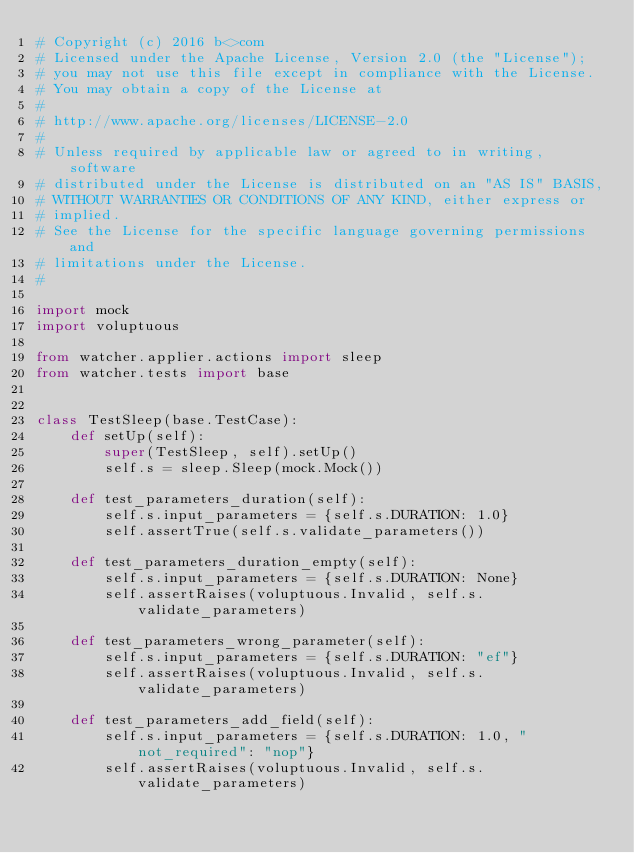Convert code to text. <code><loc_0><loc_0><loc_500><loc_500><_Python_># Copyright (c) 2016 b<>com
# Licensed under the Apache License, Version 2.0 (the "License");
# you may not use this file except in compliance with the License.
# You may obtain a copy of the License at
#
# http://www.apache.org/licenses/LICENSE-2.0
#
# Unless required by applicable law or agreed to in writing, software
# distributed under the License is distributed on an "AS IS" BASIS,
# WITHOUT WARRANTIES OR CONDITIONS OF ANY KIND, either express or
# implied.
# See the License for the specific language governing permissions and
# limitations under the License.
#

import mock
import voluptuous

from watcher.applier.actions import sleep
from watcher.tests import base


class TestSleep(base.TestCase):
    def setUp(self):
        super(TestSleep, self).setUp()
        self.s = sleep.Sleep(mock.Mock())

    def test_parameters_duration(self):
        self.s.input_parameters = {self.s.DURATION: 1.0}
        self.assertTrue(self.s.validate_parameters())

    def test_parameters_duration_empty(self):
        self.s.input_parameters = {self.s.DURATION: None}
        self.assertRaises(voluptuous.Invalid, self.s.validate_parameters)

    def test_parameters_wrong_parameter(self):
        self.s.input_parameters = {self.s.DURATION: "ef"}
        self.assertRaises(voluptuous.Invalid, self.s.validate_parameters)

    def test_parameters_add_field(self):
        self.s.input_parameters = {self.s.DURATION: 1.0, "not_required": "nop"}
        self.assertRaises(voluptuous.Invalid, self.s.validate_parameters)
</code> 